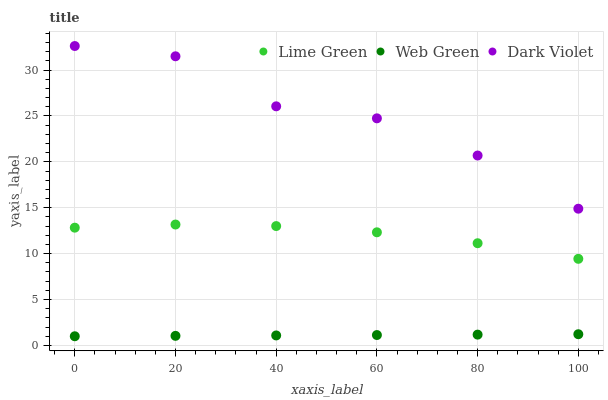Does Web Green have the minimum area under the curve?
Answer yes or no. Yes. Does Dark Violet have the maximum area under the curve?
Answer yes or no. Yes. Does Dark Violet have the minimum area under the curve?
Answer yes or no. No. Does Web Green have the maximum area under the curve?
Answer yes or no. No. Is Web Green the smoothest?
Answer yes or no. Yes. Is Dark Violet the roughest?
Answer yes or no. Yes. Is Dark Violet the smoothest?
Answer yes or no. No. Is Web Green the roughest?
Answer yes or no. No. Does Web Green have the lowest value?
Answer yes or no. Yes. Does Dark Violet have the lowest value?
Answer yes or no. No. Does Dark Violet have the highest value?
Answer yes or no. Yes. Does Web Green have the highest value?
Answer yes or no. No. Is Web Green less than Dark Violet?
Answer yes or no. Yes. Is Dark Violet greater than Web Green?
Answer yes or no. Yes. Does Web Green intersect Dark Violet?
Answer yes or no. No. 